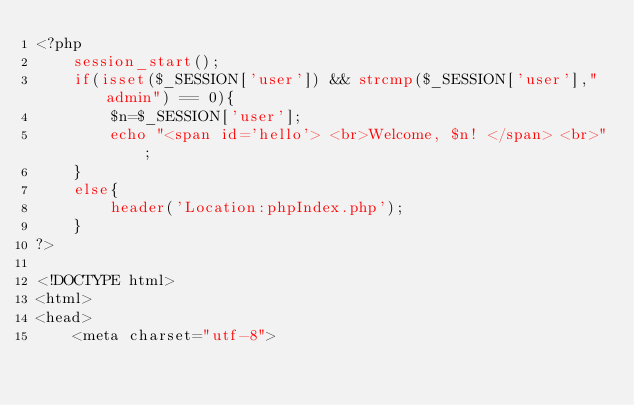<code> <loc_0><loc_0><loc_500><loc_500><_PHP_><?php 
	session_start();
	if(isset($_SESSION['user']) && strcmp($_SESSION['user'],"admin") == 0){
		$n=$_SESSION['user'];
		echo "<span id='hello'> <br>Welcome, $n! </span> <br>";
	}
	else{
		header('Location:phpIndex.php');
	}
?>

<!DOCTYPE html>
<html>
<head>
	<meta charset="utf-8"></code> 